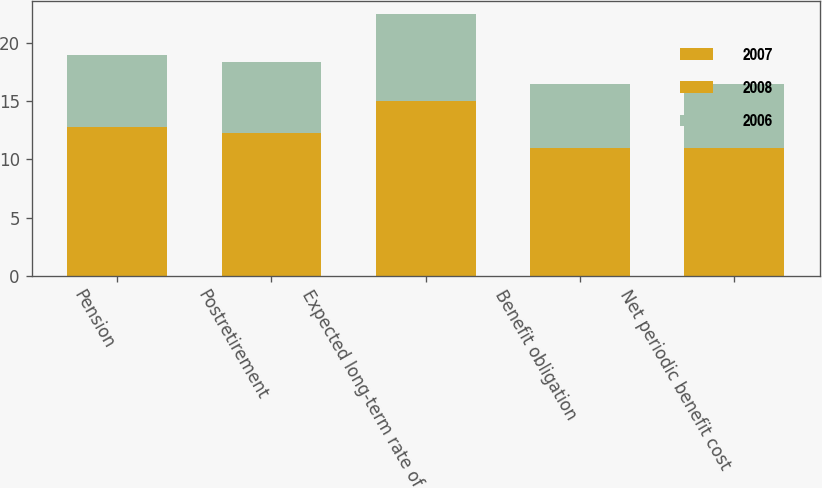<chart> <loc_0><loc_0><loc_500><loc_500><stacked_bar_chart><ecel><fcel>Pension<fcel>Postretirement<fcel>Expected long-term rate of<fcel>Benefit obligation<fcel>Net periodic benefit cost<nl><fcel>2007<fcel>6.75<fcel>6.24<fcel>7.5<fcel>5.5<fcel>5.5<nl><fcel>2008<fcel>6<fcel>5.99<fcel>7.5<fcel>5.5<fcel>5.5<nl><fcel>2006<fcel>6.23<fcel>6.16<fcel>7.5<fcel>5.5<fcel>5.5<nl></chart> 